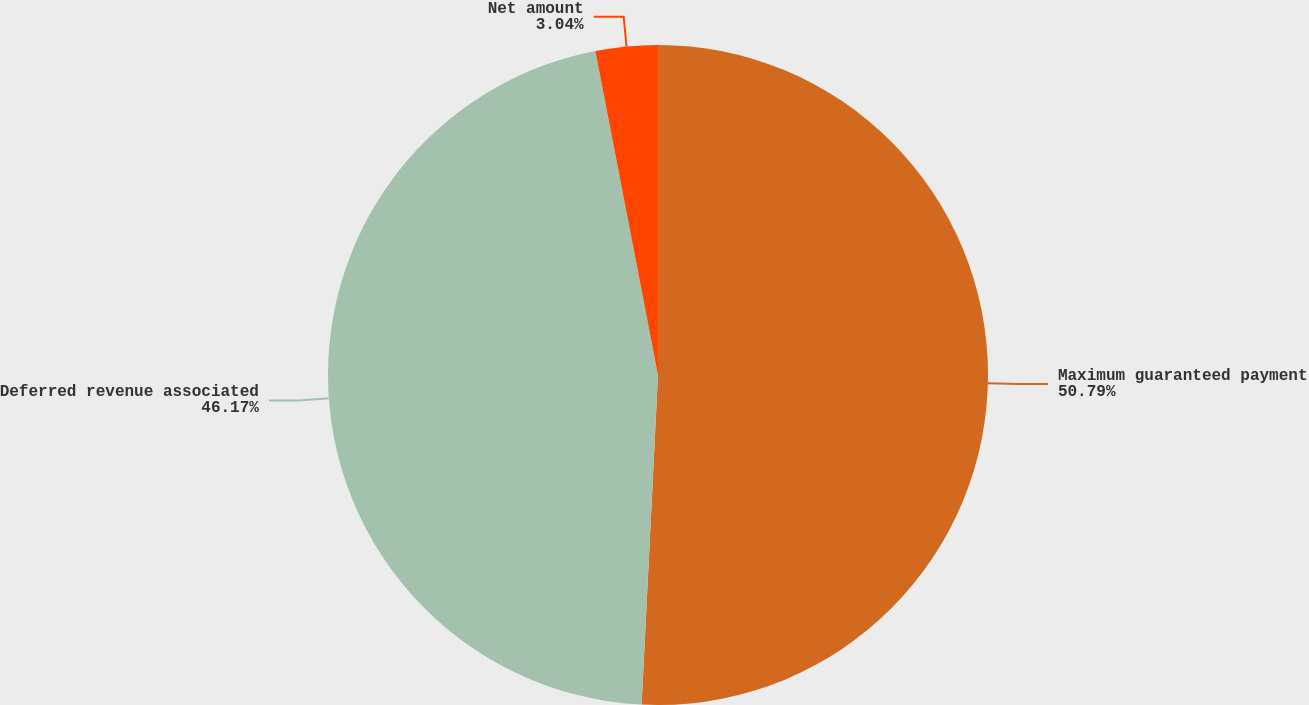Convert chart. <chart><loc_0><loc_0><loc_500><loc_500><pie_chart><fcel>Maximum guaranteed payment<fcel>Deferred revenue associated<fcel>Net amount<nl><fcel>50.79%<fcel>46.17%<fcel>3.04%<nl></chart> 